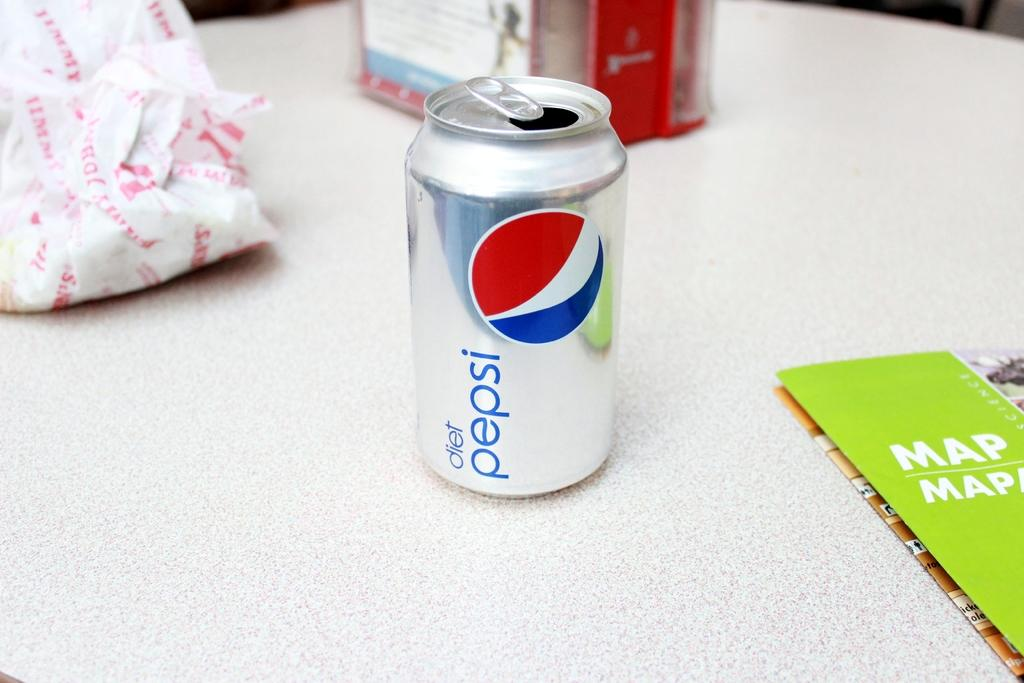<image>
Share a concise interpretation of the image provided. White can that says the words Diet Pepsi on it. 